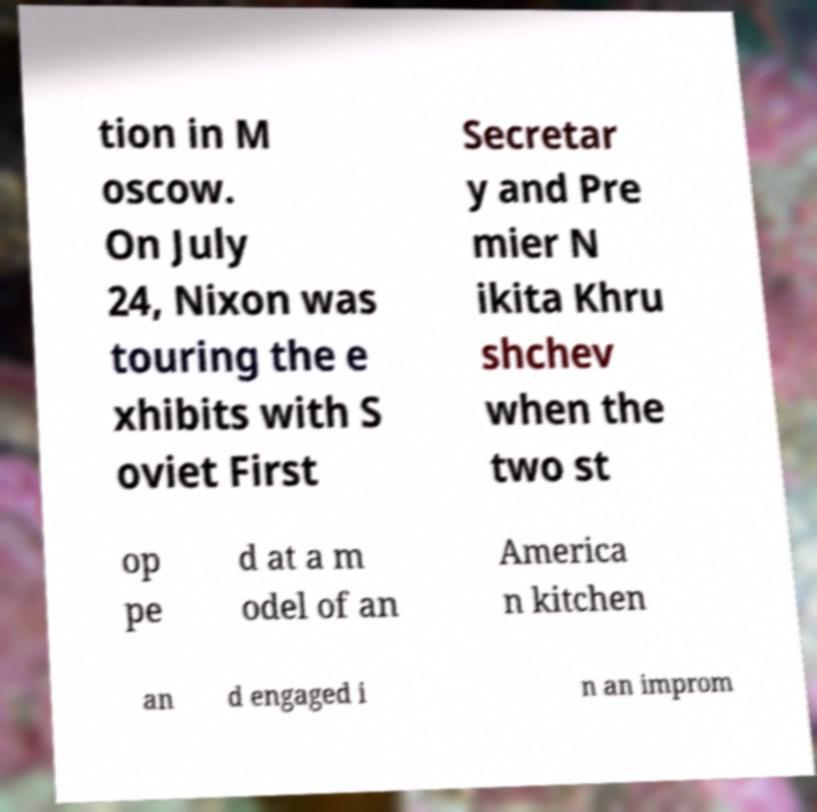For documentation purposes, I need the text within this image transcribed. Could you provide that? tion in M oscow. On July 24, Nixon was touring the e xhibits with S oviet First Secretar y and Pre mier N ikita Khru shchev when the two st op pe d at a m odel of an America n kitchen an d engaged i n an improm 